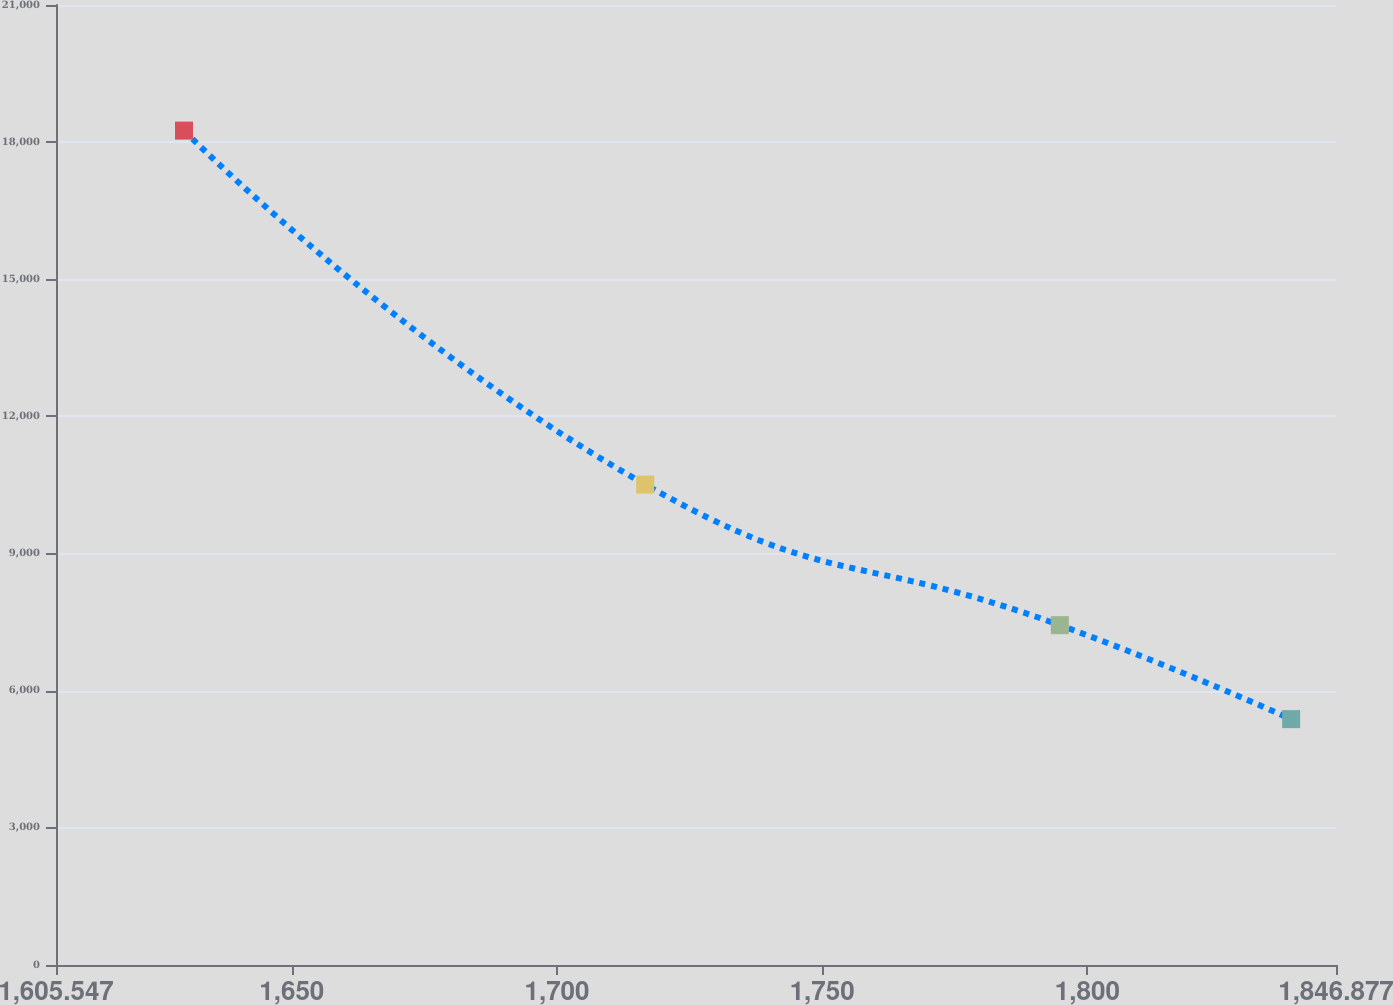<chart> <loc_0><loc_0><loc_500><loc_500><line_chart><ecel><fcel>Unnamed: 1<nl><fcel>1629.68<fcel>18252.3<nl><fcel>1716.64<fcel>10510<nl><fcel>1794.81<fcel>7433.83<nl><fcel>1838.42<fcel>5378.03<nl><fcel>1871.01<fcel>3947.55<nl></chart> 